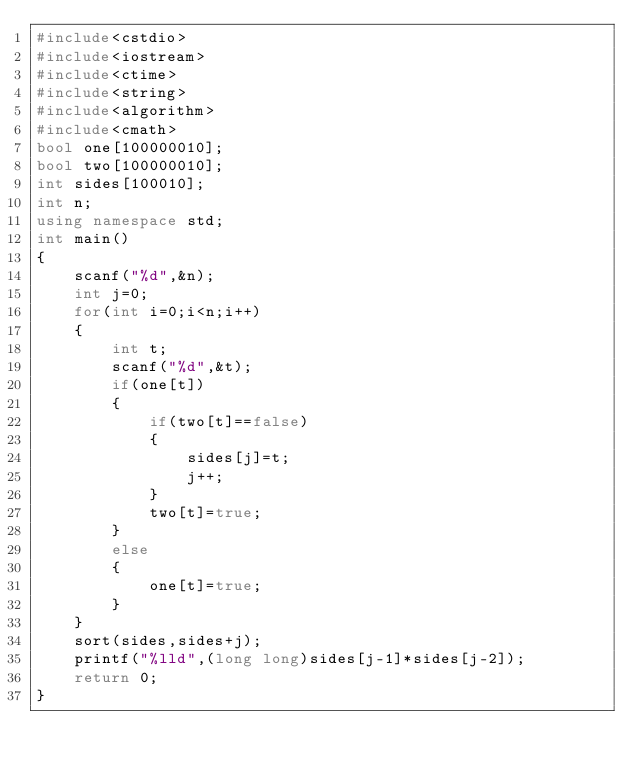<code> <loc_0><loc_0><loc_500><loc_500><_C++_>#include<cstdio>
#include<iostream>
#include<ctime>
#include<string>
#include<algorithm>
#include<cmath>
bool one[100000010];
bool two[100000010];
int sides[100010];
int n;
using namespace std;
int main()
{
	scanf("%d",&n);
	int j=0;
	for(int i=0;i<n;i++)
	{
		int t;
		scanf("%d",&t);
		if(one[t])
		{
			if(two[t]==false)
			{
				sides[j]=t;
				j++;
			}
			two[t]=true;
		}
		else
		{
			one[t]=true;
		}
	}
	sort(sides,sides+j);
	printf("%lld",(long long)sides[j-1]*sides[j-2]);
	return 0;
}
</code> 